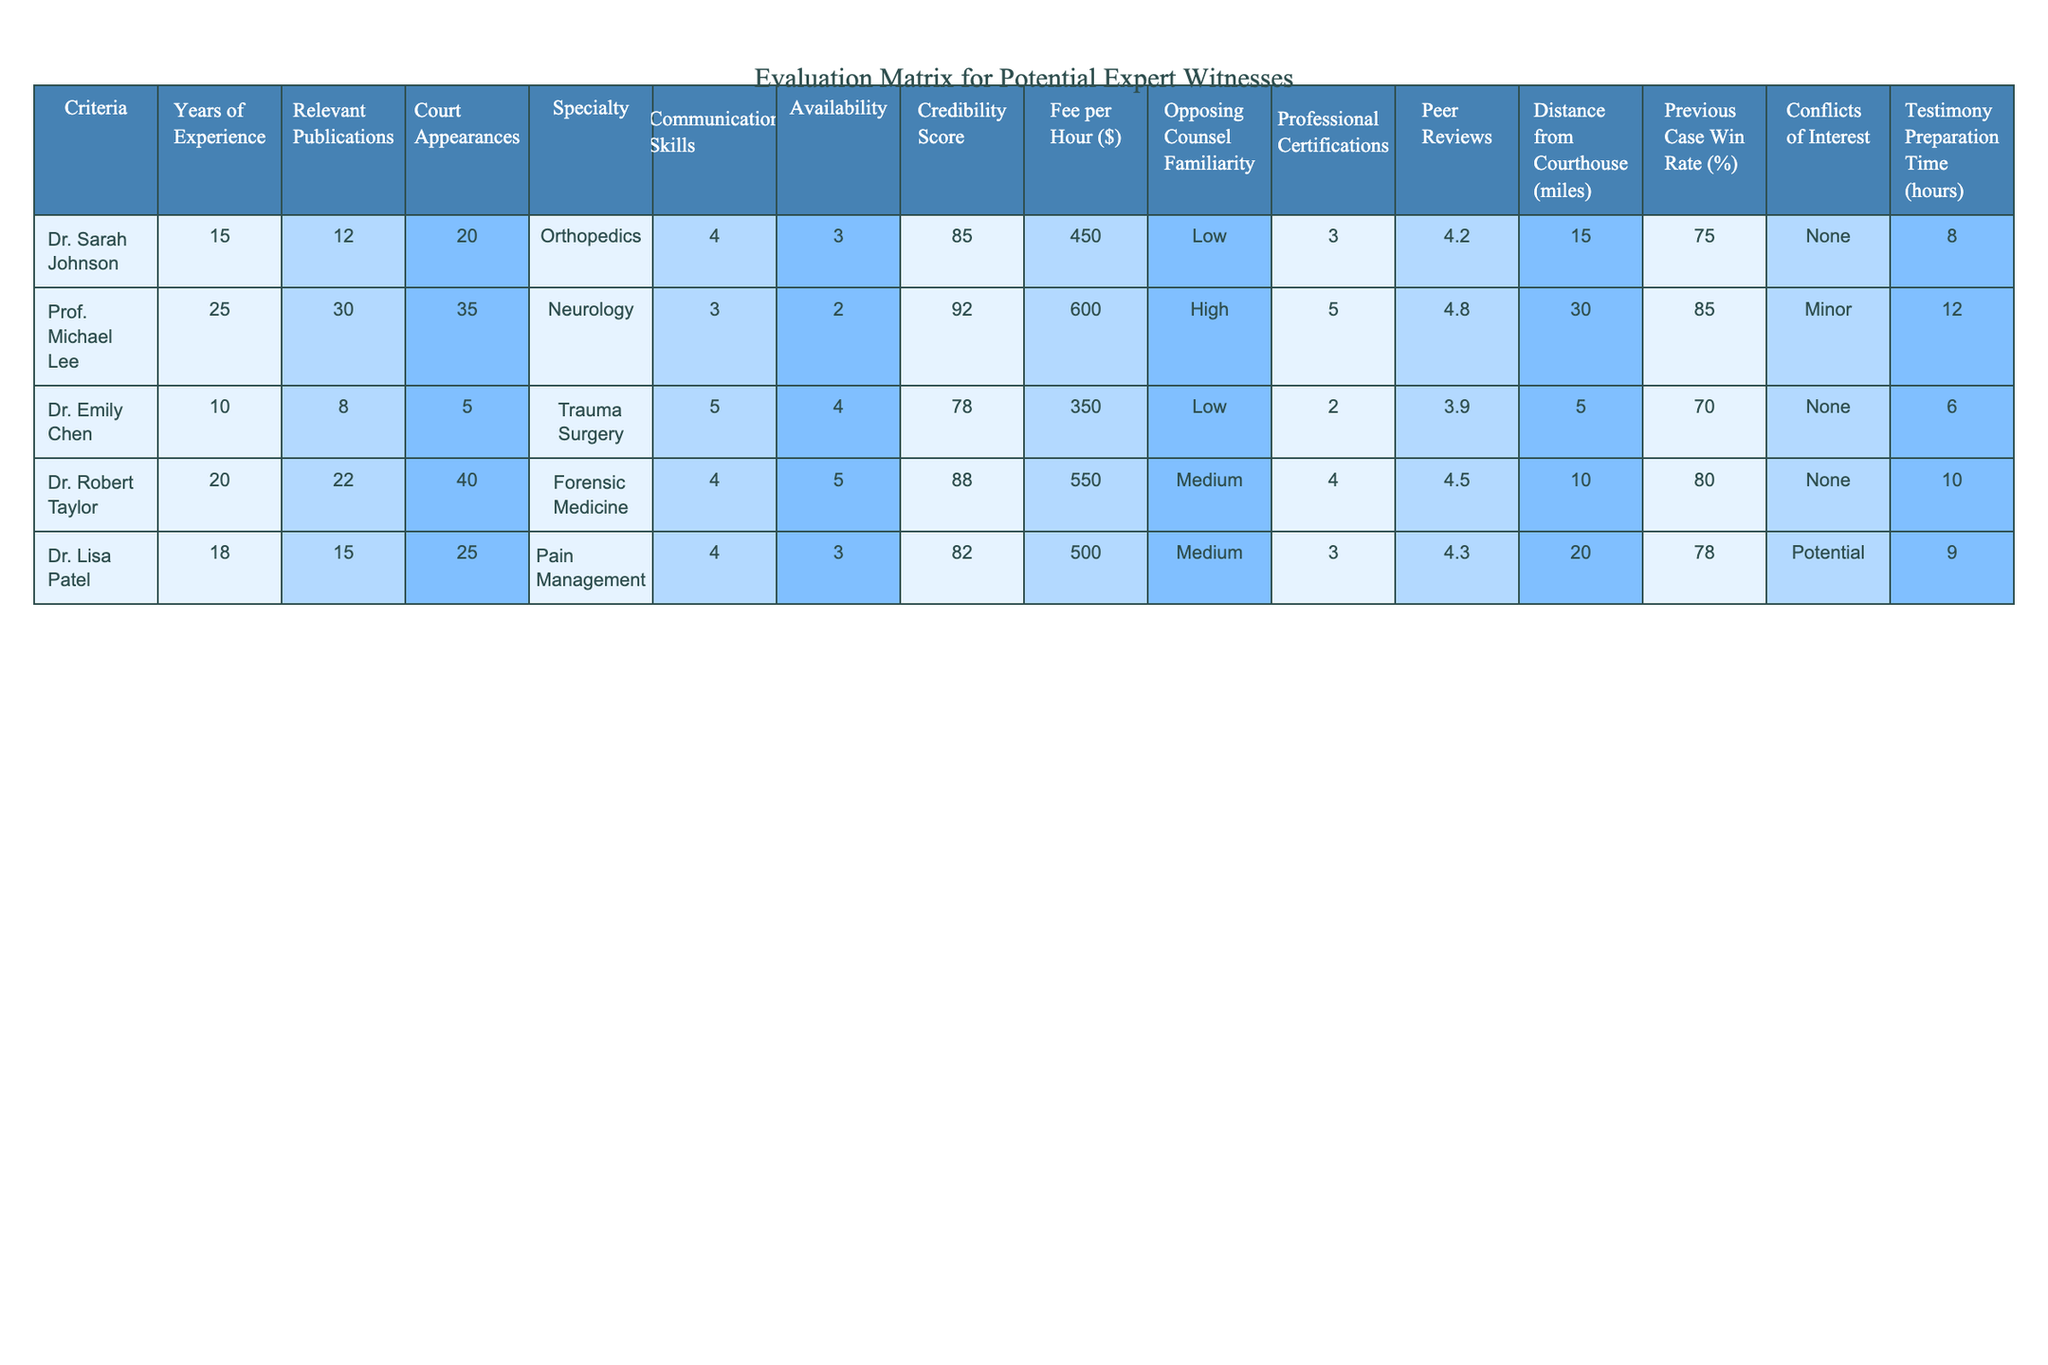What is the fee per hour for Dr. Emily Chen? The table shows that Dr. Emily Chen has a fee of $350 per hour.
Answer: $350 Which expert witness has the highest number of court appearances? By looking at the court appearances column, Prof. Michael Lee has the highest number with 35 appearances.
Answer: Prof. Michael Lee What is the average years of experience among all the expert witnesses? The years of experience for all witnesses are 15, 25, 10, 20, and 18. Adding these gives: 15 + 25 + 10 + 20 + 18 = 88. Dividing by the number of witnesses (5) gives an average of 88/5 = 17.6.
Answer: 17.6 Is there any expert witness with a credibility score above 90? Looking through the credibility scores, only Prof. Michael Lee has a score of 92, which is above 90.
Answer: Yes Which witness has the most professional certifications? Dr. Robert Taylor and Prof. Michael Lee both have 5 certifications, which is the highest among the experts listed.
Answer: Prof. Michael Lee and Dr. Robert Taylor What is the difference between the previous case win rates of Dr. Lisa Patel and Prof. Michael Lee? Dr. Lisa Patel has a win rate of 78% and Prof. Michael Lee has 85%. The difference is 85 - 78 = 7%.
Answer: 7% How many expert witnesses have a conflict of interest listed? By reviewing the conflicts of interest column, it appears that Dr. Lisa Patel has a potential conflict, while the others have none or minor conflicts. Therefore, there is one witness with a conflict of interest.
Answer: 1 Which expert has the best communication skills? Analyzing the communication skills scores, Dr. Emily Chen has the highest score of 5.
Answer: Dr. Emily Chen What is the total number of relevant publications from all expert witnesses? The relevant publications are 12, 30, 8, 22, and 15. Adding these together gives 12 + 30 + 8 + 22 + 15 = 87 relevant publications in total.
Answer: 87 